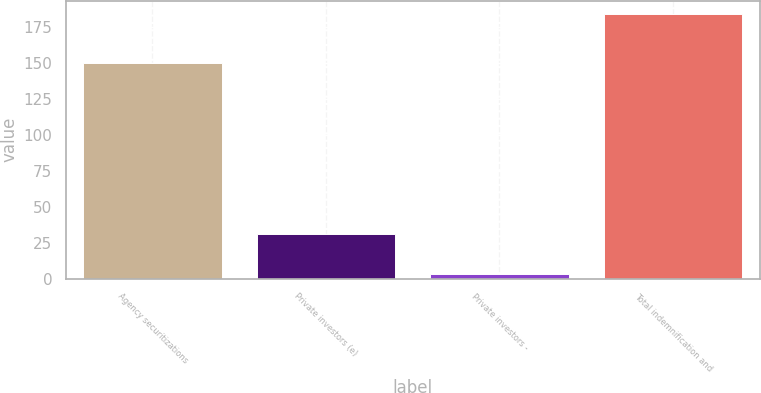Convert chart. <chart><loc_0><loc_0><loc_500><loc_500><bar_chart><fcel>Agency securitizations<fcel>Private investors (e)<fcel>Private investors -<fcel>Total indemnification and<nl><fcel>150<fcel>31<fcel>3<fcel>184<nl></chart> 